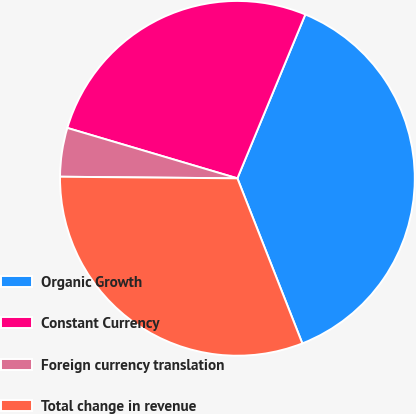<chart> <loc_0><loc_0><loc_500><loc_500><pie_chart><fcel>Organic Growth<fcel>Constant Currency<fcel>Foreign currency translation<fcel>Total change in revenue<nl><fcel>37.78%<fcel>26.67%<fcel>4.44%<fcel>31.11%<nl></chart> 